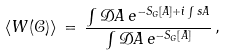Convert formula to latex. <formula><loc_0><loc_0><loc_500><loc_500>\langle W ( { \mathcal { C } } ) \rangle \, = \, \frac { \int { \mathcal { D } } A \, e ^ { - S _ { G } [ A ] + i \int s A } } { \int { \mathcal { D } } A \, e ^ { - S _ { G } [ A ] } } \, ,</formula> 